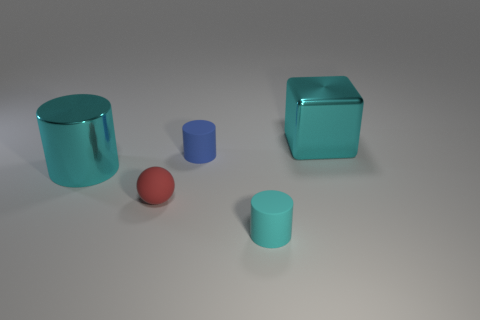Are there any reflective surfaces visible among the objects? Yes, all objects display reflective surfaces, indicating that they have a shiny, perhaps metallic or glass-like material. Can you tell what the light source in the scene might be like? Given the soft shadows and diffused reflections, the light source could be an overhead diffused light, perhaps in an indoor setting. 